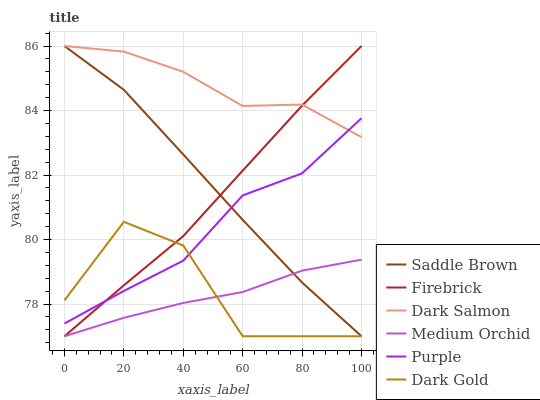Does Purple have the minimum area under the curve?
Answer yes or no. No. Does Purple have the maximum area under the curve?
Answer yes or no. No. Is Purple the smoothest?
Answer yes or no. No. Is Purple the roughest?
Answer yes or no. No. Does Purple have the lowest value?
Answer yes or no. No. Does Purple have the highest value?
Answer yes or no. No. Is Medium Orchid less than Dark Salmon?
Answer yes or no. Yes. Is Purple greater than Medium Orchid?
Answer yes or no. Yes. Does Medium Orchid intersect Dark Salmon?
Answer yes or no. No. 